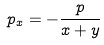Convert formula to latex. <formula><loc_0><loc_0><loc_500><loc_500>p _ { x } = - \frac { p } { x + y }</formula> 